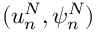Convert formula to latex. <formula><loc_0><loc_0><loc_500><loc_500>( u _ { n } ^ { N } , \psi _ { n } ^ { N } )</formula> 